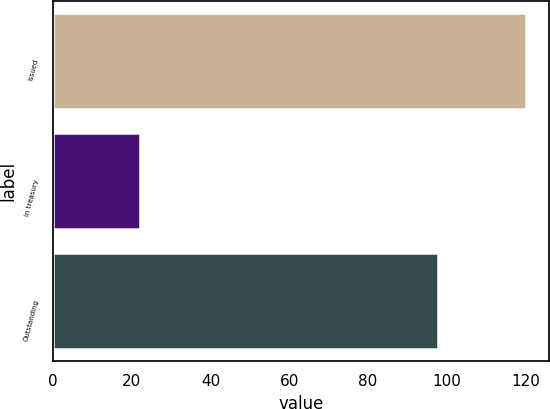<chart> <loc_0><loc_0><loc_500><loc_500><bar_chart><fcel>Issued<fcel>In treasury<fcel>Outstanding<nl><fcel>120<fcel>22.2<fcel>97.8<nl></chart> 